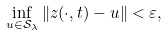<formula> <loc_0><loc_0><loc_500><loc_500>\inf _ { u \in \mathcal { S } _ { \lambda } } \| z ( \cdot , t ) - u \| < \varepsilon ,</formula> 